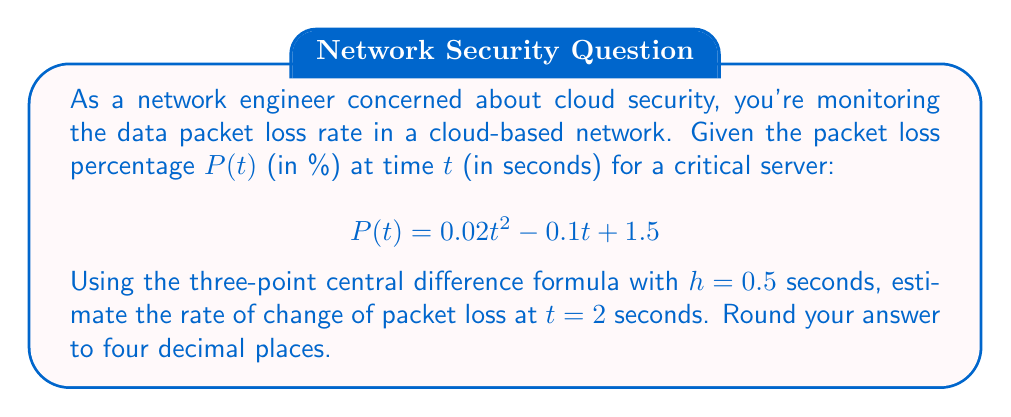Can you answer this question? To solve this problem, we'll use the three-point central difference formula for numerical differentiation:

$$f'(x) \approx \frac{f(x+h) - f(x-h)}{2h}$$

Where $f(x)$ is our function $P(t)$, $x$ is our point of interest $t=2$, and $h=0.5$.

Steps:
1) Calculate $P(t-h)$, $P(t+h)$:
   $P(2-0.5) = P(1.5)$ and $P(2+0.5) = P(2.5)$

2) $P(1.5) = 0.02(1.5)^2 - 0.1(1.5) + 1.5$
           $= 0.02(2.25) - 0.15 + 1.5$
           $= 0.045 - 0.15 + 1.5 = 1.395$

3) $P(2.5) = 0.02(2.5)^2 - 0.1(2.5) + 1.5$
           $= 0.02(6.25) - 0.25 + 1.5$
           $= 0.125 - 0.25 + 1.5 = 1.375$

4) Apply the formula:
   $$P'(2) \approx \frac{P(2.5) - P(1.5)}{2(0.5)}$$
   $$= \frac{1.375 - 1.395}{1} = -0.02$$

5) Round to four decimal places: -0.0200

This negative value indicates that the packet loss rate is decreasing at $t=2$ seconds.
Answer: -0.0200 %/s 